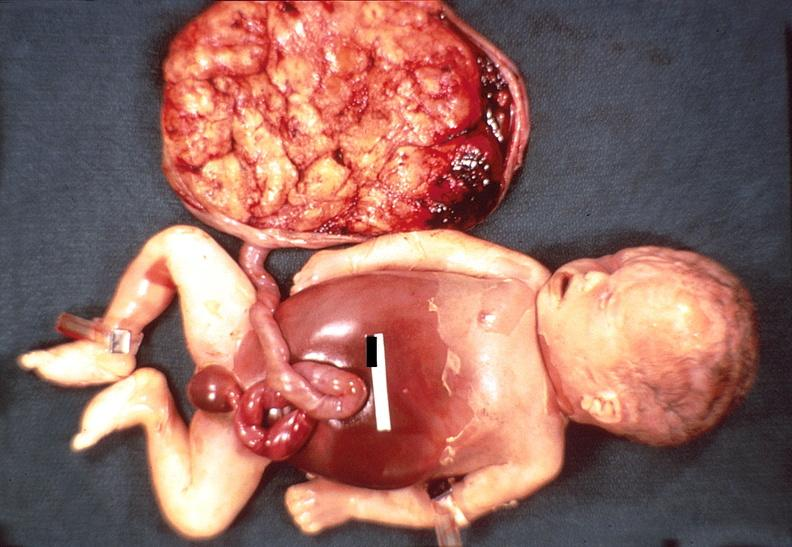what does this image show?
Answer the question using a single word or phrase. Hemolytic disease of newborn 